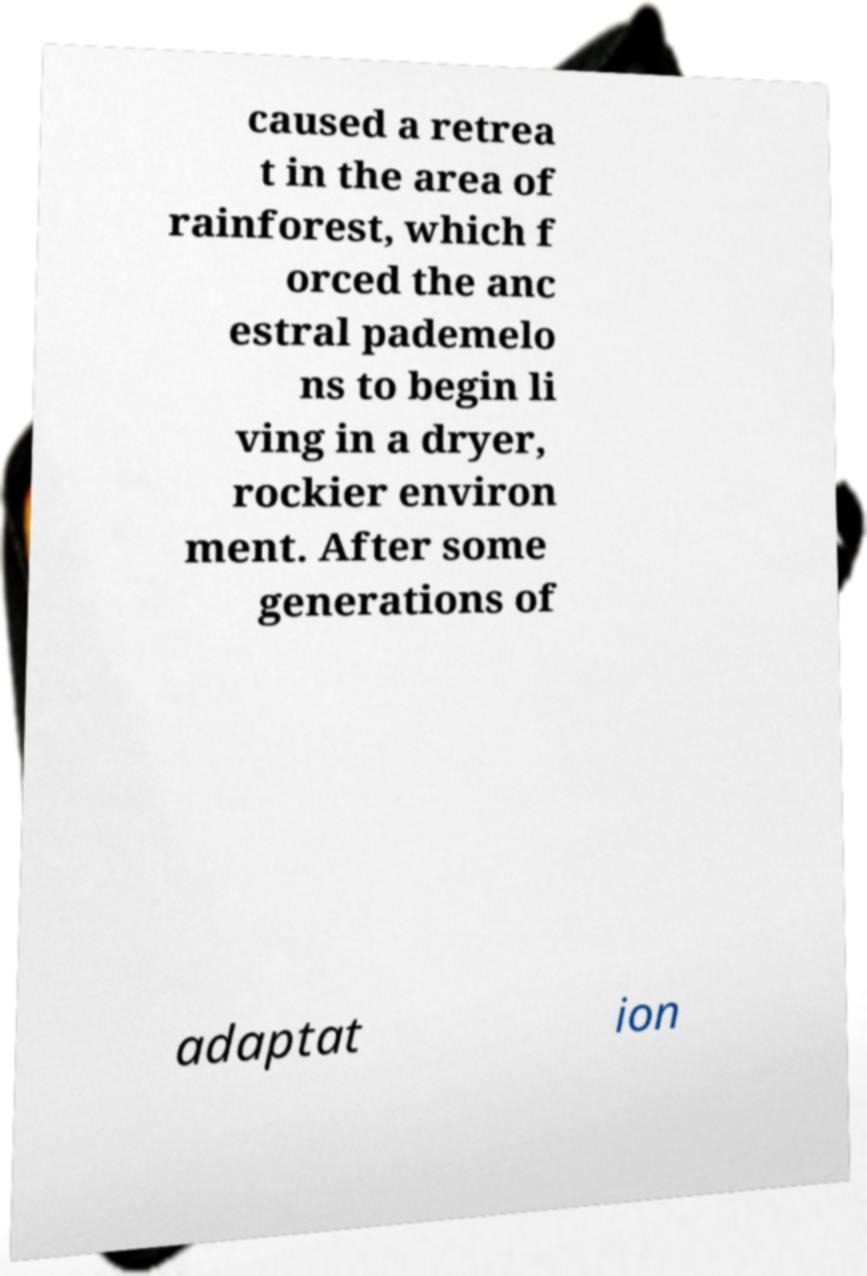Please read and relay the text visible in this image. What does it say? caused a retrea t in the area of rainforest, which f orced the anc estral pademelo ns to begin li ving in a dryer, rockier environ ment. After some generations of adaptat ion 